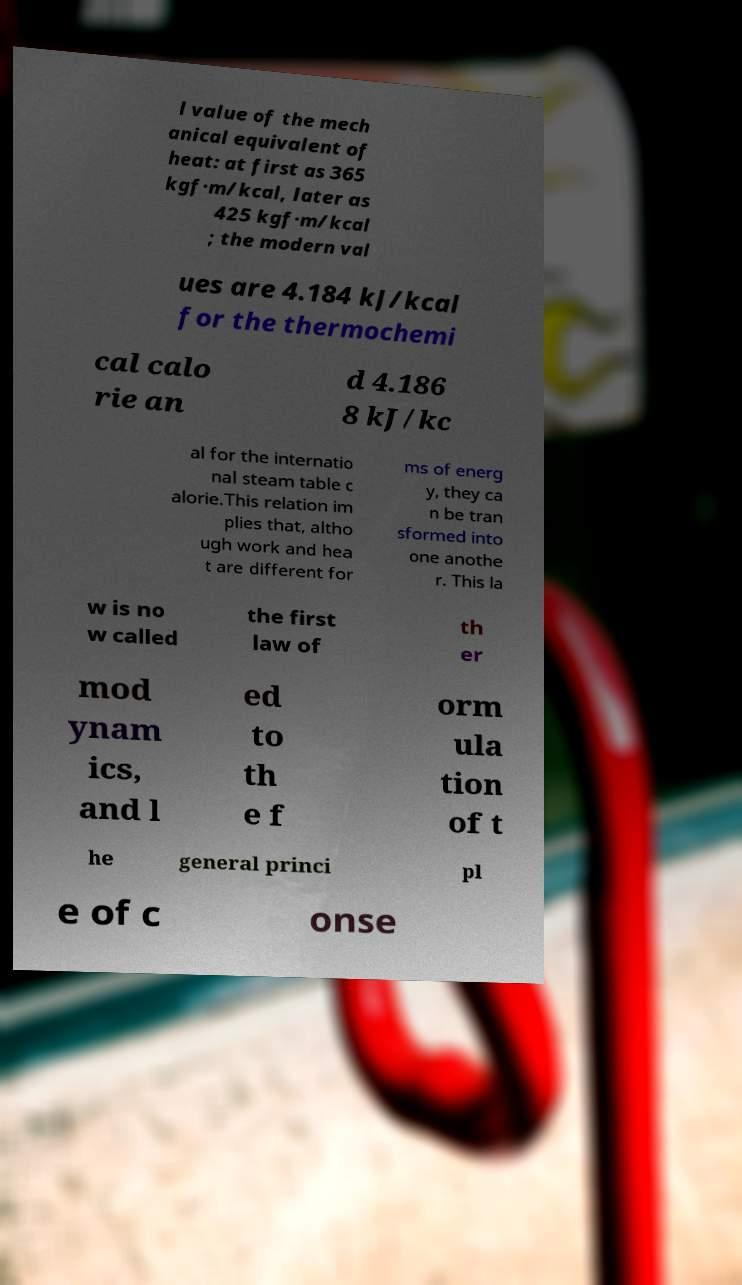There's text embedded in this image that I need extracted. Can you transcribe it verbatim? l value of the mech anical equivalent of heat: at first as 365 kgf·m/kcal, later as 425 kgf·m/kcal ; the modern val ues are 4.184 kJ/kcal for the thermochemi cal calo rie an d 4.186 8 kJ/kc al for the internatio nal steam table c alorie.This relation im plies that, altho ugh work and hea t are different for ms of energ y, they ca n be tran sformed into one anothe r. This la w is no w called the first law of th er mod ynam ics, and l ed to th e f orm ula tion of t he general princi pl e of c onse 